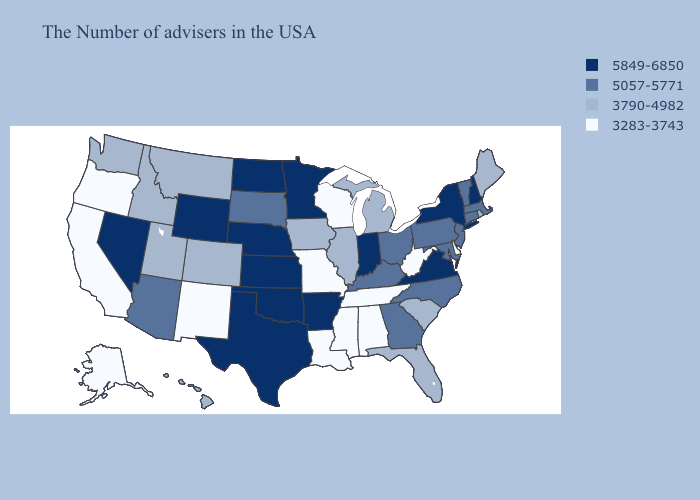What is the value of Oregon?
Keep it brief. 3283-3743. Name the states that have a value in the range 5849-6850?
Quick response, please. New Hampshire, New York, Virginia, Indiana, Arkansas, Minnesota, Kansas, Nebraska, Oklahoma, Texas, North Dakota, Wyoming, Nevada. Name the states that have a value in the range 5849-6850?
Quick response, please. New Hampshire, New York, Virginia, Indiana, Arkansas, Minnesota, Kansas, Nebraska, Oklahoma, Texas, North Dakota, Wyoming, Nevada. Does Tennessee have a lower value than Connecticut?
Be succinct. Yes. Is the legend a continuous bar?
Short answer required. No. What is the value of Washington?
Write a very short answer. 3790-4982. Does Colorado have the lowest value in the West?
Answer briefly. No. Name the states that have a value in the range 3790-4982?
Short answer required. Maine, Rhode Island, South Carolina, Florida, Michigan, Illinois, Iowa, Colorado, Utah, Montana, Idaho, Washington, Hawaii. What is the value of New Hampshire?
Keep it brief. 5849-6850. Which states have the lowest value in the West?
Keep it brief. New Mexico, California, Oregon, Alaska. Which states have the lowest value in the USA?
Short answer required. Delaware, West Virginia, Alabama, Tennessee, Wisconsin, Mississippi, Louisiana, Missouri, New Mexico, California, Oregon, Alaska. Does South Dakota have a lower value than Wyoming?
Short answer required. Yes. Does Nevada have the highest value in the USA?
Give a very brief answer. Yes. Does Minnesota have a lower value than West Virginia?
Give a very brief answer. No. Does the map have missing data?
Keep it brief. No. 